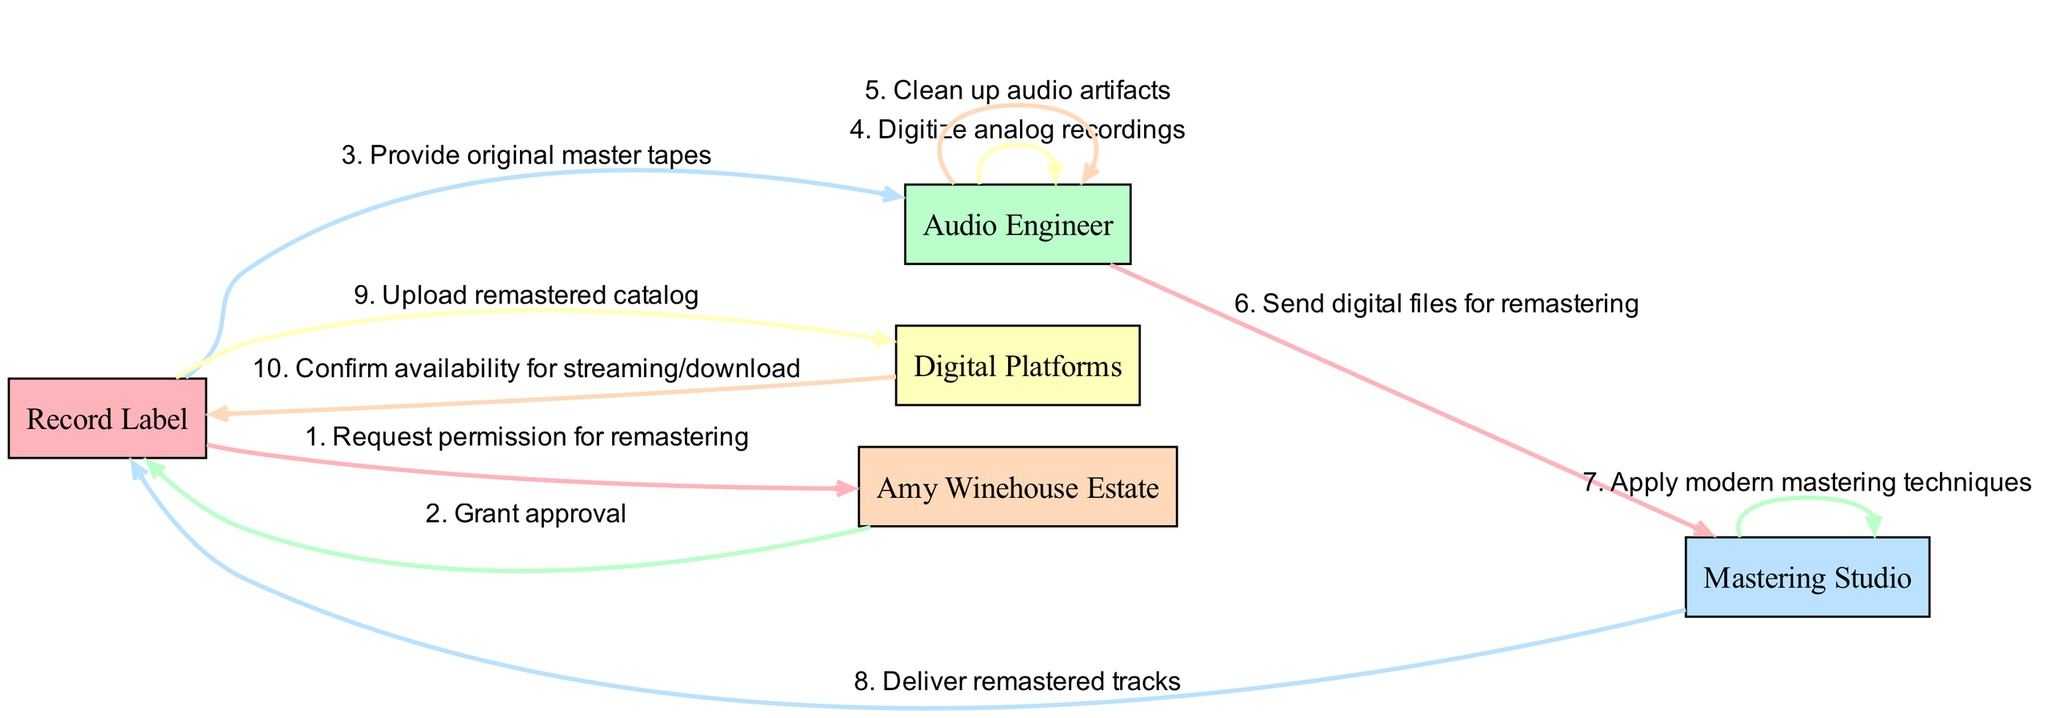What is the first message in the sequence? The first message in the sequence is from the Record Label to the Amy Winehouse Estate requesting permission to remaster her music.
Answer: Request permission for remastering Who is responsible for digitizing the analog recordings? The Audio Engineer is responsible for digitizing the analog recordings, as indicated in the sequence diagram.
Answer: Audio Engineer What is the last entity to confirm the completion of the process? The last entity to confirm the completion of the process is the Digital Platforms, who respond back to the Record Label.
Answer: Digital Platforms How many participants are shown in the diagram? There are five participants in the diagram, which are listed in the sequence.
Answer: Five What is the role of the Mastering Studio in this process? The role of the Mastering Studio is to apply modern mastering techniques to the digital files received from the Audio Engineer.
Answer: Apply modern mastering techniques How many messages are exchanged between the Record Label and the Audio Engineer? There are two messages exchanged between the Record Label and the Audio Engineer: one providing original master tapes and one sending digital files for remastering.
Answer: Two Which participant approves the remastering request? The Amy Winehouse Estate approves the remastering request from the Record Label.
Answer: Amy Winehouse Estate What occurs right after remastered tracks are delivered? Right after the remastered tracks are delivered, the Record Label uploads the remastered catalog to digital platforms.
Answer: Upload remastered catalog What technique is applied by the Mastering Studio? The Mastering Studio applies modern mastering techniques.
Answer: Modern mastering techniques 